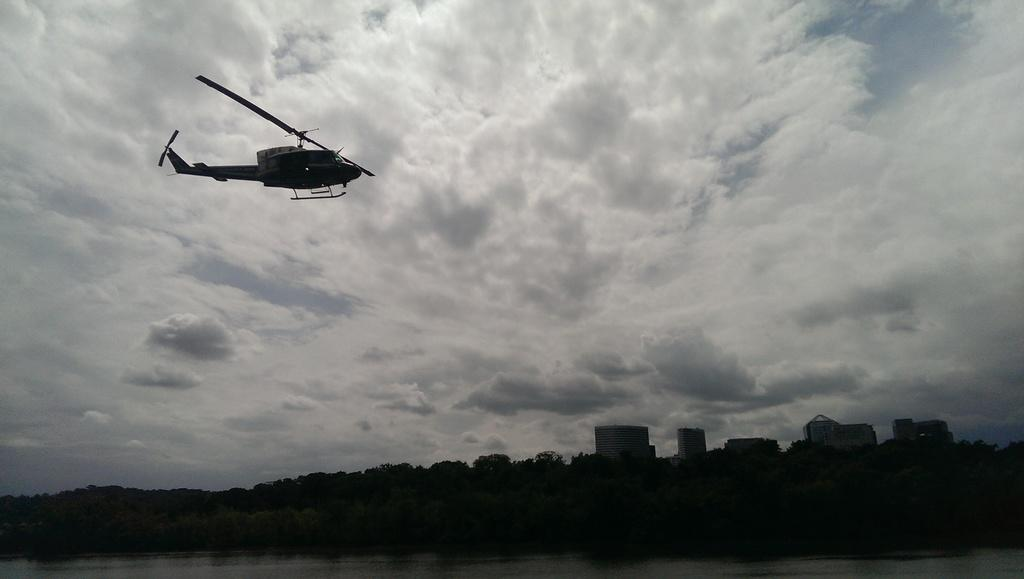What is the main subject of the image? The main subject of the image is a helicopter. What is the helicopter doing in the image? The helicopter is flying in the air. What can be seen in the background of the image? There are clouds in the sky in the background of the image. What is visible at the bottom of the image? There are buildings and trees at the bottom of the image. What type of shoe can be seen resting on the helicopter's wing in the image? There is no shoe present in the image, and the helicopter's wing is not visible in the image. What is the weather like in the image? The weather cannot be determined from the image, as only clouds are visible in the sky. 